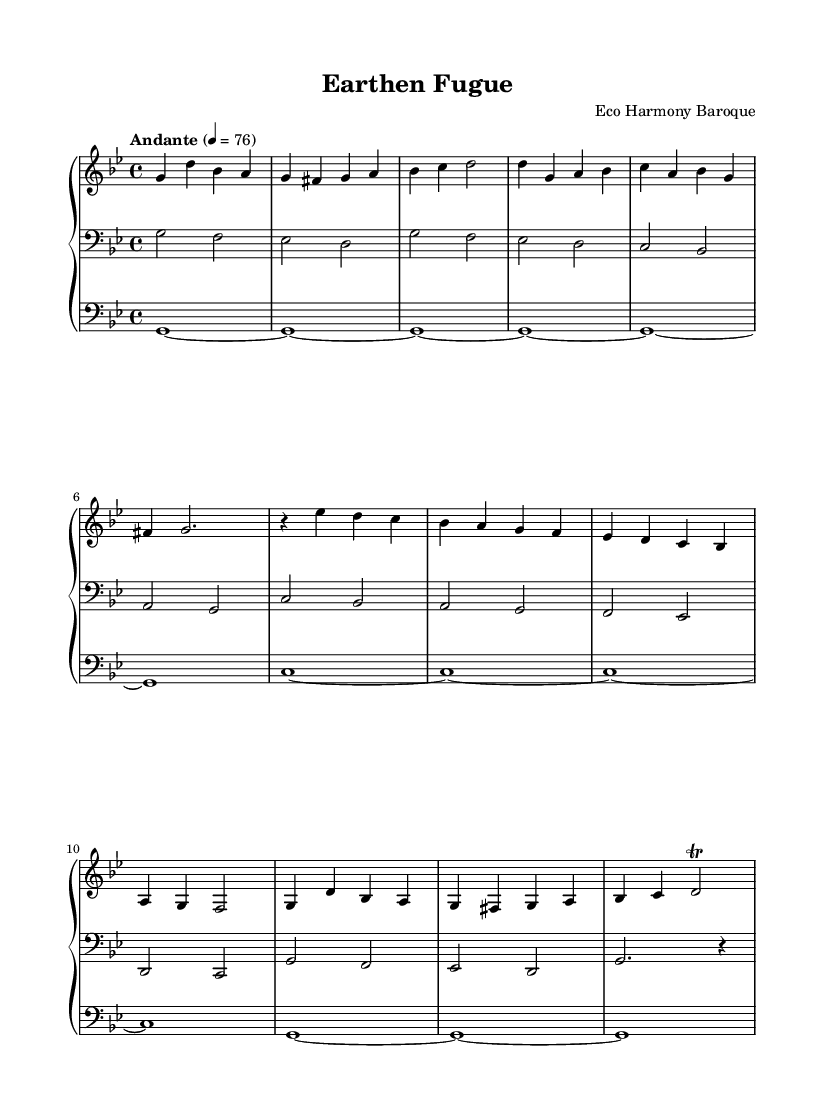What is the key signature of this music? The key signature is G minor, which has two flats (B♭ and E♭) indicated. This can be seen at the beginning of the sheet music.
Answer: G minor What is the time signature of this music? The time signature is 4/4, which indicates that there are four beats in each measure and that the quarter note receives one beat. This is noted at the beginning of the sheet music.
Answer: 4/4 What is the tempo marking of this piece? The tempo marking is "Andante", which is a moderate walking speed, indicated above the staff in the sheet music. This reflects the overall pace at which the piece should be played.
Answer: Andante How many measures are in the exposition? The exposition consists of 8 measures. By counting the individual measures from the beginning to the end of the exposition section in the sheet music, we find there are 8 measures in total.
Answer: 8 What type of ornamentation is used in the recapitulation? A trill is used in the recapitulation, specifically indicated by the tr symbol above the note in measure 7 of the recapitulation. This ornament adds embellishment to the note.
Answer: Trill What is the highest note in this piece? The highest note in this piece is D, which can be found in the right hand's melody near the end of the first section and also during the recapitulation.
Answer: D How many distinct sections are indicated in the work? There are three distinct sections indicated: Exposition, Development, and Recapitulation. The structure of the piece is explicitly labeled at the beginning of each section in the sheet music.
Answer: Three 